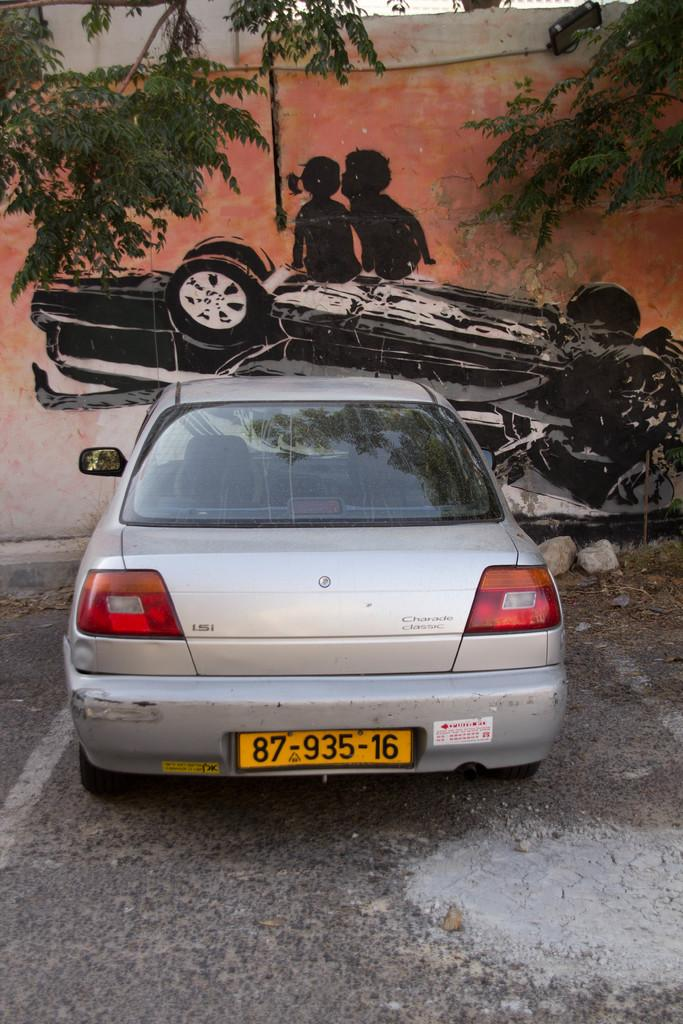<image>
Share a concise interpretation of the image provided. a silver car with the license plate 87 935 16is parked by a wall with a car wreck mural 